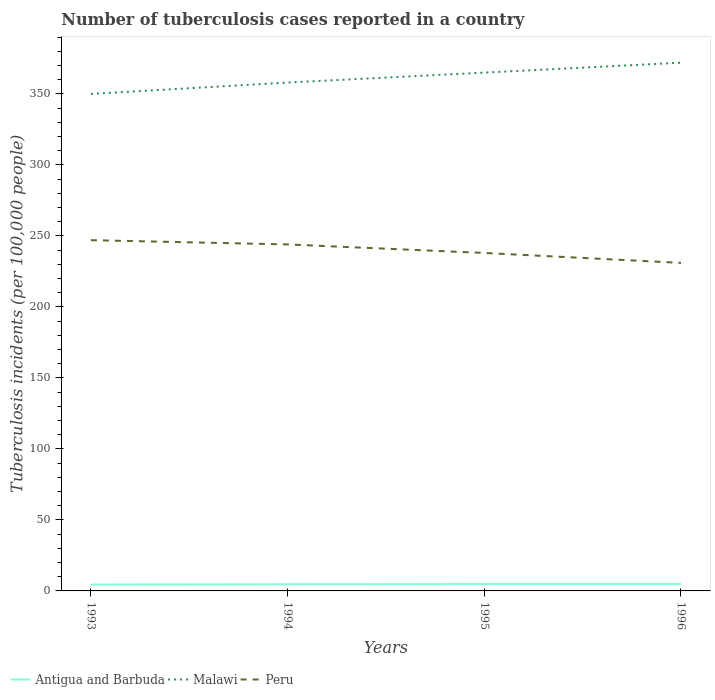Does the line corresponding to Peru intersect with the line corresponding to Antigua and Barbuda?
Your response must be concise. No. Across all years, what is the maximum number of tuberculosis cases reported in in Peru?
Provide a short and direct response. 231. In which year was the number of tuberculosis cases reported in in Peru maximum?
Ensure brevity in your answer.  1996. What is the total number of tuberculosis cases reported in in Antigua and Barbuda in the graph?
Ensure brevity in your answer.  -0.4. What is the difference between the highest and the second highest number of tuberculosis cases reported in in Antigua and Barbuda?
Make the answer very short. 0.4. Is the number of tuberculosis cases reported in in Malawi strictly greater than the number of tuberculosis cases reported in in Antigua and Barbuda over the years?
Keep it short and to the point. No. Does the graph contain grids?
Provide a succinct answer. No. Where does the legend appear in the graph?
Your response must be concise. Bottom left. How many legend labels are there?
Give a very brief answer. 3. How are the legend labels stacked?
Provide a succinct answer. Horizontal. What is the title of the graph?
Your answer should be compact. Number of tuberculosis cases reported in a country. What is the label or title of the X-axis?
Offer a terse response. Years. What is the label or title of the Y-axis?
Provide a succinct answer. Tuberculosis incidents (per 100,0 people). What is the Tuberculosis incidents (per 100,000 people) of Malawi in 1993?
Offer a terse response. 350. What is the Tuberculosis incidents (per 100,000 people) of Peru in 1993?
Your answer should be very brief. 247. What is the Tuberculosis incidents (per 100,000 people) of Malawi in 1994?
Your answer should be compact. 358. What is the Tuberculosis incidents (per 100,000 people) in Peru in 1994?
Your response must be concise. 244. What is the Tuberculosis incidents (per 100,000 people) in Antigua and Barbuda in 1995?
Ensure brevity in your answer.  4.9. What is the Tuberculosis incidents (per 100,000 people) in Malawi in 1995?
Offer a terse response. 365. What is the Tuberculosis incidents (per 100,000 people) in Peru in 1995?
Give a very brief answer. 238. What is the Tuberculosis incidents (per 100,000 people) of Antigua and Barbuda in 1996?
Provide a succinct answer. 4.9. What is the Tuberculosis incidents (per 100,000 people) of Malawi in 1996?
Your response must be concise. 372. What is the Tuberculosis incidents (per 100,000 people) of Peru in 1996?
Give a very brief answer. 231. Across all years, what is the maximum Tuberculosis incidents (per 100,000 people) in Malawi?
Give a very brief answer. 372. Across all years, what is the maximum Tuberculosis incidents (per 100,000 people) of Peru?
Your answer should be compact. 247. Across all years, what is the minimum Tuberculosis incidents (per 100,000 people) in Antigua and Barbuda?
Ensure brevity in your answer.  4.5. Across all years, what is the minimum Tuberculosis incidents (per 100,000 people) in Malawi?
Give a very brief answer. 350. Across all years, what is the minimum Tuberculosis incidents (per 100,000 people) of Peru?
Your answer should be compact. 231. What is the total Tuberculosis incidents (per 100,000 people) in Malawi in the graph?
Offer a very short reply. 1445. What is the total Tuberculosis incidents (per 100,000 people) of Peru in the graph?
Provide a succinct answer. 960. What is the difference between the Tuberculosis incidents (per 100,000 people) in Malawi in 1993 and that in 1994?
Keep it short and to the point. -8. What is the difference between the Tuberculosis incidents (per 100,000 people) in Malawi in 1993 and that in 1995?
Offer a terse response. -15. What is the difference between the Tuberculosis incidents (per 100,000 people) of Peru in 1993 and that in 1996?
Your answer should be very brief. 16. What is the difference between the Tuberculosis incidents (per 100,000 people) of Malawi in 1994 and that in 1995?
Keep it short and to the point. -7. What is the difference between the Tuberculosis incidents (per 100,000 people) in Antigua and Barbuda in 1994 and that in 1996?
Offer a very short reply. -0.2. What is the difference between the Tuberculosis incidents (per 100,000 people) in Malawi in 1994 and that in 1996?
Offer a terse response. -14. What is the difference between the Tuberculosis incidents (per 100,000 people) in Peru in 1994 and that in 1996?
Offer a very short reply. 13. What is the difference between the Tuberculosis incidents (per 100,000 people) in Peru in 1995 and that in 1996?
Your response must be concise. 7. What is the difference between the Tuberculosis incidents (per 100,000 people) of Antigua and Barbuda in 1993 and the Tuberculosis incidents (per 100,000 people) of Malawi in 1994?
Your answer should be very brief. -353.5. What is the difference between the Tuberculosis incidents (per 100,000 people) in Antigua and Barbuda in 1993 and the Tuberculosis incidents (per 100,000 people) in Peru in 1994?
Provide a succinct answer. -239.5. What is the difference between the Tuberculosis incidents (per 100,000 people) in Malawi in 1993 and the Tuberculosis incidents (per 100,000 people) in Peru in 1994?
Ensure brevity in your answer.  106. What is the difference between the Tuberculosis incidents (per 100,000 people) of Antigua and Barbuda in 1993 and the Tuberculosis incidents (per 100,000 people) of Malawi in 1995?
Provide a succinct answer. -360.5. What is the difference between the Tuberculosis incidents (per 100,000 people) of Antigua and Barbuda in 1993 and the Tuberculosis incidents (per 100,000 people) of Peru in 1995?
Your response must be concise. -233.5. What is the difference between the Tuberculosis incidents (per 100,000 people) of Malawi in 1993 and the Tuberculosis incidents (per 100,000 people) of Peru in 1995?
Offer a very short reply. 112. What is the difference between the Tuberculosis incidents (per 100,000 people) of Antigua and Barbuda in 1993 and the Tuberculosis incidents (per 100,000 people) of Malawi in 1996?
Offer a very short reply. -367.5. What is the difference between the Tuberculosis incidents (per 100,000 people) of Antigua and Barbuda in 1993 and the Tuberculosis incidents (per 100,000 people) of Peru in 1996?
Make the answer very short. -226.5. What is the difference between the Tuberculosis incidents (per 100,000 people) of Malawi in 1993 and the Tuberculosis incidents (per 100,000 people) of Peru in 1996?
Offer a very short reply. 119. What is the difference between the Tuberculosis incidents (per 100,000 people) of Antigua and Barbuda in 1994 and the Tuberculosis incidents (per 100,000 people) of Malawi in 1995?
Give a very brief answer. -360.3. What is the difference between the Tuberculosis incidents (per 100,000 people) of Antigua and Barbuda in 1994 and the Tuberculosis incidents (per 100,000 people) of Peru in 1995?
Ensure brevity in your answer.  -233.3. What is the difference between the Tuberculosis incidents (per 100,000 people) of Malawi in 1994 and the Tuberculosis incidents (per 100,000 people) of Peru in 1995?
Ensure brevity in your answer.  120. What is the difference between the Tuberculosis incidents (per 100,000 people) in Antigua and Barbuda in 1994 and the Tuberculosis incidents (per 100,000 people) in Malawi in 1996?
Your response must be concise. -367.3. What is the difference between the Tuberculosis incidents (per 100,000 people) of Antigua and Barbuda in 1994 and the Tuberculosis incidents (per 100,000 people) of Peru in 1996?
Offer a terse response. -226.3. What is the difference between the Tuberculosis incidents (per 100,000 people) of Malawi in 1994 and the Tuberculosis incidents (per 100,000 people) of Peru in 1996?
Make the answer very short. 127. What is the difference between the Tuberculosis incidents (per 100,000 people) in Antigua and Barbuda in 1995 and the Tuberculosis incidents (per 100,000 people) in Malawi in 1996?
Give a very brief answer. -367.1. What is the difference between the Tuberculosis incidents (per 100,000 people) in Antigua and Barbuda in 1995 and the Tuberculosis incidents (per 100,000 people) in Peru in 1996?
Give a very brief answer. -226.1. What is the difference between the Tuberculosis incidents (per 100,000 people) in Malawi in 1995 and the Tuberculosis incidents (per 100,000 people) in Peru in 1996?
Make the answer very short. 134. What is the average Tuberculosis incidents (per 100,000 people) of Antigua and Barbuda per year?
Your answer should be very brief. 4.75. What is the average Tuberculosis incidents (per 100,000 people) of Malawi per year?
Your response must be concise. 361.25. What is the average Tuberculosis incidents (per 100,000 people) of Peru per year?
Your answer should be very brief. 240. In the year 1993, what is the difference between the Tuberculosis incidents (per 100,000 people) of Antigua and Barbuda and Tuberculosis incidents (per 100,000 people) of Malawi?
Provide a succinct answer. -345.5. In the year 1993, what is the difference between the Tuberculosis incidents (per 100,000 people) in Antigua and Barbuda and Tuberculosis incidents (per 100,000 people) in Peru?
Your response must be concise. -242.5. In the year 1993, what is the difference between the Tuberculosis incidents (per 100,000 people) of Malawi and Tuberculosis incidents (per 100,000 people) of Peru?
Offer a very short reply. 103. In the year 1994, what is the difference between the Tuberculosis incidents (per 100,000 people) in Antigua and Barbuda and Tuberculosis incidents (per 100,000 people) in Malawi?
Provide a short and direct response. -353.3. In the year 1994, what is the difference between the Tuberculosis incidents (per 100,000 people) in Antigua and Barbuda and Tuberculosis incidents (per 100,000 people) in Peru?
Your answer should be compact. -239.3. In the year 1994, what is the difference between the Tuberculosis incidents (per 100,000 people) of Malawi and Tuberculosis incidents (per 100,000 people) of Peru?
Offer a terse response. 114. In the year 1995, what is the difference between the Tuberculosis incidents (per 100,000 people) of Antigua and Barbuda and Tuberculosis incidents (per 100,000 people) of Malawi?
Offer a very short reply. -360.1. In the year 1995, what is the difference between the Tuberculosis incidents (per 100,000 people) in Antigua and Barbuda and Tuberculosis incidents (per 100,000 people) in Peru?
Offer a very short reply. -233.1. In the year 1995, what is the difference between the Tuberculosis incidents (per 100,000 people) of Malawi and Tuberculosis incidents (per 100,000 people) of Peru?
Your response must be concise. 127. In the year 1996, what is the difference between the Tuberculosis incidents (per 100,000 people) of Antigua and Barbuda and Tuberculosis incidents (per 100,000 people) of Malawi?
Offer a very short reply. -367.1. In the year 1996, what is the difference between the Tuberculosis incidents (per 100,000 people) of Antigua and Barbuda and Tuberculosis incidents (per 100,000 people) of Peru?
Your answer should be compact. -226.1. In the year 1996, what is the difference between the Tuberculosis incidents (per 100,000 people) in Malawi and Tuberculosis incidents (per 100,000 people) in Peru?
Give a very brief answer. 141. What is the ratio of the Tuberculosis incidents (per 100,000 people) of Antigua and Barbuda in 1993 to that in 1994?
Give a very brief answer. 0.96. What is the ratio of the Tuberculosis incidents (per 100,000 people) of Malawi in 1993 to that in 1994?
Ensure brevity in your answer.  0.98. What is the ratio of the Tuberculosis incidents (per 100,000 people) of Peru in 1993 to that in 1994?
Offer a very short reply. 1.01. What is the ratio of the Tuberculosis incidents (per 100,000 people) of Antigua and Barbuda in 1993 to that in 1995?
Your answer should be very brief. 0.92. What is the ratio of the Tuberculosis incidents (per 100,000 people) in Malawi in 1993 to that in 1995?
Ensure brevity in your answer.  0.96. What is the ratio of the Tuberculosis incidents (per 100,000 people) of Peru in 1993 to that in 1995?
Ensure brevity in your answer.  1.04. What is the ratio of the Tuberculosis incidents (per 100,000 people) of Antigua and Barbuda in 1993 to that in 1996?
Your answer should be compact. 0.92. What is the ratio of the Tuberculosis incidents (per 100,000 people) in Malawi in 1993 to that in 1996?
Provide a succinct answer. 0.94. What is the ratio of the Tuberculosis incidents (per 100,000 people) of Peru in 1993 to that in 1996?
Ensure brevity in your answer.  1.07. What is the ratio of the Tuberculosis incidents (per 100,000 people) in Antigua and Barbuda in 1994 to that in 1995?
Ensure brevity in your answer.  0.96. What is the ratio of the Tuberculosis incidents (per 100,000 people) of Malawi in 1994 to that in 1995?
Offer a terse response. 0.98. What is the ratio of the Tuberculosis incidents (per 100,000 people) in Peru in 1994 to that in 1995?
Keep it short and to the point. 1.03. What is the ratio of the Tuberculosis incidents (per 100,000 people) in Antigua and Barbuda in 1994 to that in 1996?
Provide a short and direct response. 0.96. What is the ratio of the Tuberculosis incidents (per 100,000 people) of Malawi in 1994 to that in 1996?
Keep it short and to the point. 0.96. What is the ratio of the Tuberculosis incidents (per 100,000 people) of Peru in 1994 to that in 1996?
Ensure brevity in your answer.  1.06. What is the ratio of the Tuberculosis incidents (per 100,000 people) of Antigua and Barbuda in 1995 to that in 1996?
Ensure brevity in your answer.  1. What is the ratio of the Tuberculosis incidents (per 100,000 people) in Malawi in 1995 to that in 1996?
Provide a succinct answer. 0.98. What is the ratio of the Tuberculosis incidents (per 100,000 people) in Peru in 1995 to that in 1996?
Offer a terse response. 1.03. What is the difference between the highest and the second highest Tuberculosis incidents (per 100,000 people) in Peru?
Your answer should be compact. 3. What is the difference between the highest and the lowest Tuberculosis incidents (per 100,000 people) in Antigua and Barbuda?
Your response must be concise. 0.4. What is the difference between the highest and the lowest Tuberculosis incidents (per 100,000 people) in Malawi?
Your answer should be compact. 22. 